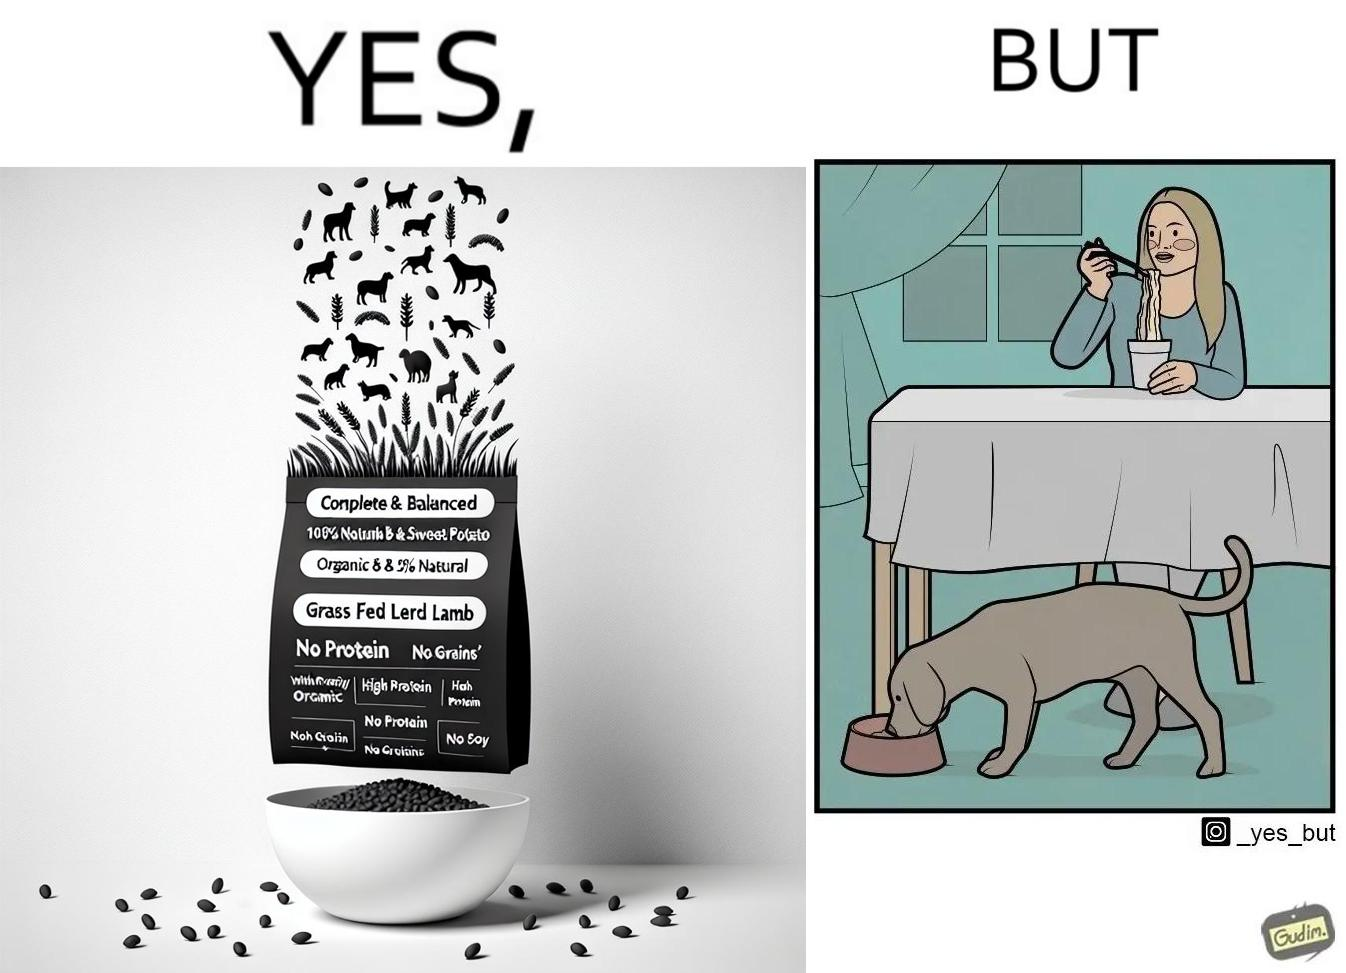Is this image satirical or non-satirical? Yes, this image is satirical. 